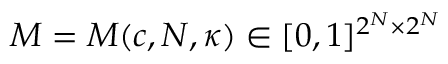Convert formula to latex. <formula><loc_0><loc_0><loc_500><loc_500>M = M ( c , N , \kappa ) \in [ 0 , 1 ] ^ { 2 ^ { N } \times 2 ^ { N } }</formula> 